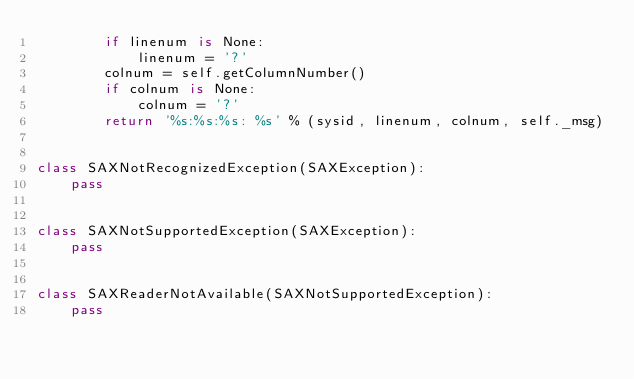Convert code to text. <code><loc_0><loc_0><loc_500><loc_500><_Python_>        if linenum is None:
            linenum = '?'
        colnum = self.getColumnNumber()
        if colnum is None:
            colnum = '?'
        return '%s:%s:%s: %s' % (sysid, linenum, colnum, self._msg)


class SAXNotRecognizedException(SAXException):
    pass


class SAXNotSupportedException(SAXException):
    pass


class SAXReaderNotAvailable(SAXNotSupportedException):
    pass</code> 